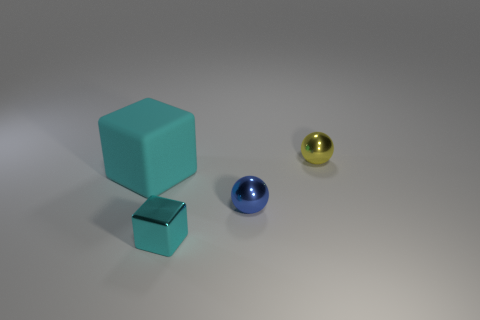What color is the thing that is both to the left of the small blue object and on the right side of the matte thing?
Offer a very short reply. Cyan. There is another object that is the same shape as the yellow metal object; what is its size?
Ensure brevity in your answer.  Small. How many green metal things have the same size as the cyan shiny thing?
Your response must be concise. 0. What is the material of the large thing?
Offer a terse response. Rubber. Are there any large rubber blocks behind the blue object?
Give a very brief answer. Yes. The cube that is made of the same material as the yellow thing is what size?
Give a very brief answer. Small. What number of large things have the same color as the small metal cube?
Provide a short and direct response. 1. Is the number of tiny cyan metallic things to the right of the blue metal object less than the number of blue balls behind the small block?
Make the answer very short. Yes. There is a sphere in front of the large object; what is its size?
Your answer should be very brief. Small. There is a metallic object that is the same color as the large matte block; what is its size?
Your response must be concise. Small. 